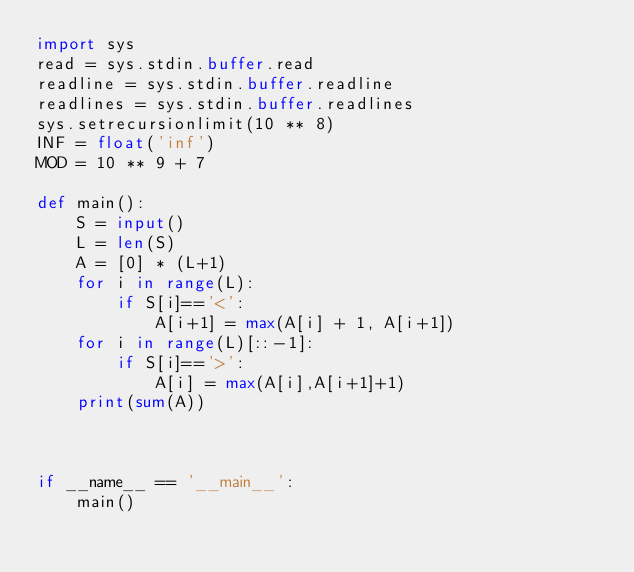Convert code to text. <code><loc_0><loc_0><loc_500><loc_500><_Python_>import sys
read = sys.stdin.buffer.read
readline = sys.stdin.buffer.readline
readlines = sys.stdin.buffer.readlines
sys.setrecursionlimit(10 ** 8)
INF = float('inf')
MOD = 10 ** 9 + 7

def main():
    S = input()
    L = len(S)
    A = [0] * (L+1)
    for i in range(L):
        if S[i]=='<':
            A[i+1] = max(A[i] + 1, A[i+1])
    for i in range(L)[::-1]:
        if S[i]=='>':
            A[i] = max(A[i],A[i+1]+1)
    print(sum(A))



if __name__ == '__main__':
    main()</code> 